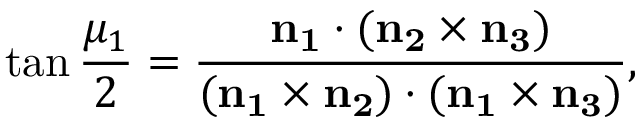<formula> <loc_0><loc_0><loc_500><loc_500>\tan { \frac { \mu _ { 1 } } 2 } = \frac { n _ { 1 } \cdot ( n _ { 2 } \times n _ { 3 } ) } { ( n _ { 1 } \times n _ { 2 } ) \cdot ( n _ { 1 } \times n _ { 3 } ) } ,</formula> 